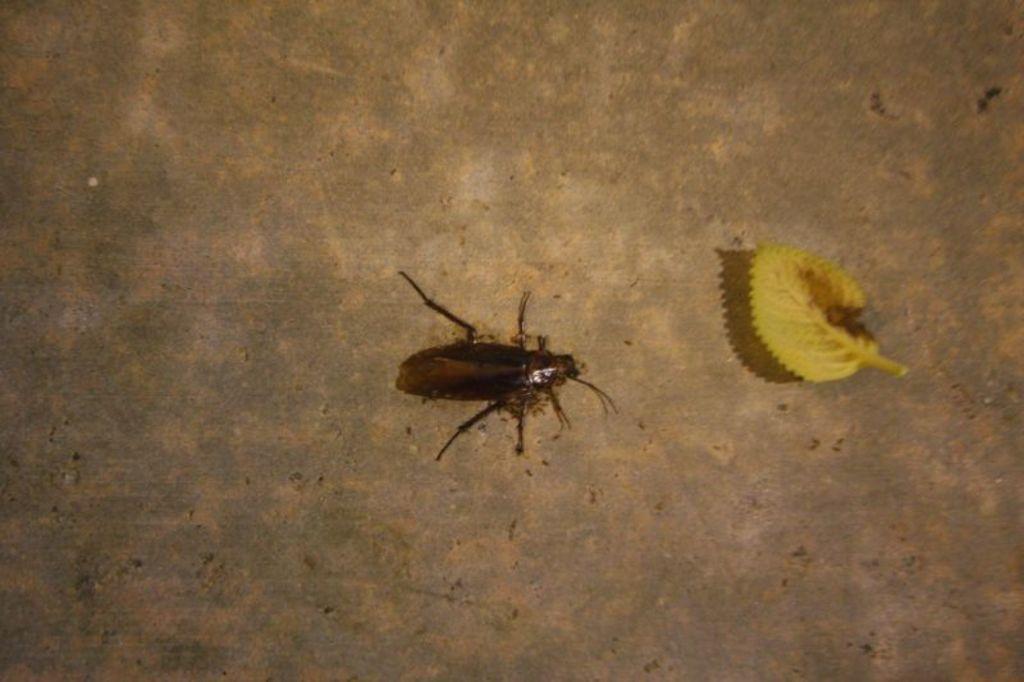Can you describe this image briefly? In this image I can see the insect in brown and black color and yellow color leaf. They are on the brown surface. 